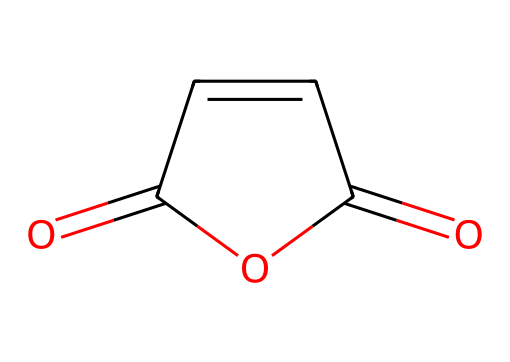What is the molecular formula of maleic anhydride? The SMILES structure indicates the presence of two carbonyl groups (O=C) and a carbon backbone, which corresponds to the molecular formula C4H2O3.
Answer: C4H2O3 How many carbon atoms are in maleic anhydride? By examining the SMILES structure, we see there are four carbon atoms present in the entire molecule.
Answer: 4 What type of compound is maleic anhydride? Maleic anhydride falls under the category of anhydrides due to its formation from maleic acid by the removal of a water molecule, evidenced by the anhydride bond in its structure.
Answer: anhydride What is the total number of oxygen atoms in maleic anhydride? Looking at the structure, there are three oxygen atoms visible: two in the carbonyl (C=O) groups and one in the cyclic structure, totaling three.
Answer: 3 How many double bonds are present in maleic anhydride? The structure shows two double bonds, one in each of the carbonyl (C=O) functional groups of the molecule.
Answer: 2 What kind of reaction can maleic anhydride undergo because of its functional groups? The presence of the carbonyl groups in maleic anhydride facilitates nucleophilic addition reactions, making it reactive towards nucleophiles.
Answer: nucleophilic addition Does maleic anhydride contain aromatic rings? By analyzing the chemical structure, it can be observed that there are no aromatic rings present; the compound has a cyclic structure but it's not aromatic.
Answer: no 